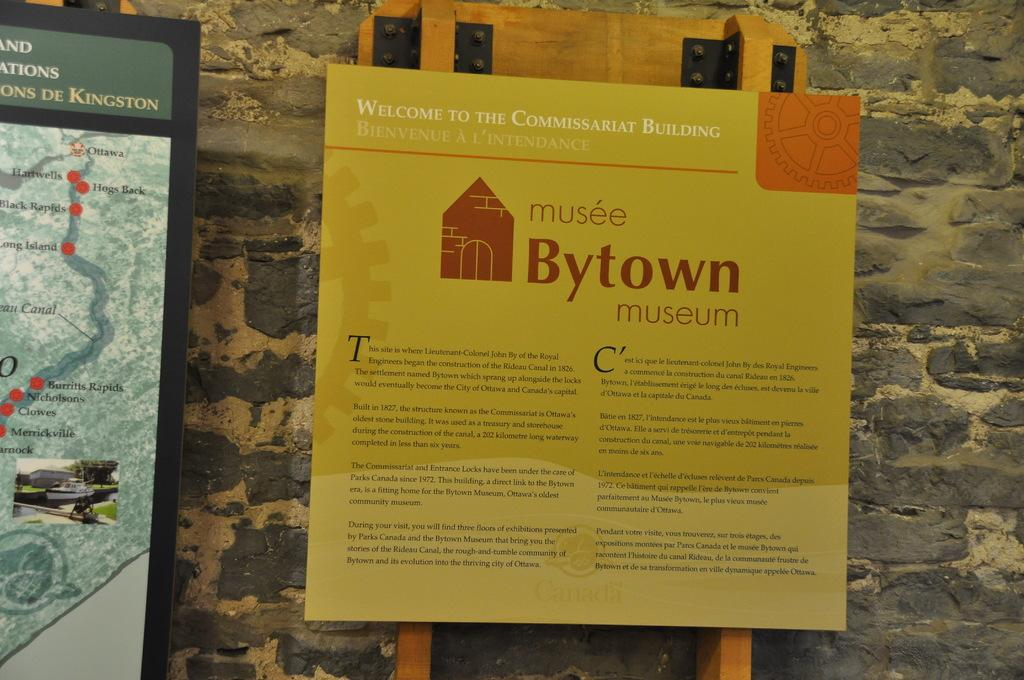Provide a one-sentence caption for the provided image. A flyer for Bytown museum is shown on a wall. 